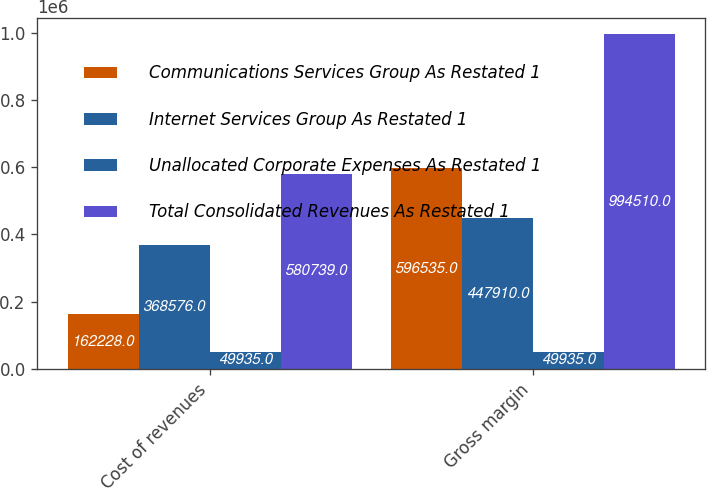Convert chart. <chart><loc_0><loc_0><loc_500><loc_500><stacked_bar_chart><ecel><fcel>Cost of revenues<fcel>Gross margin<nl><fcel>Communications Services Group As Restated 1<fcel>162228<fcel>596535<nl><fcel>Internet Services Group As Restated 1<fcel>368576<fcel>447910<nl><fcel>Unallocated Corporate Expenses As Restated 1<fcel>49935<fcel>49935<nl><fcel>Total Consolidated Revenues As Restated 1<fcel>580739<fcel>994510<nl></chart> 